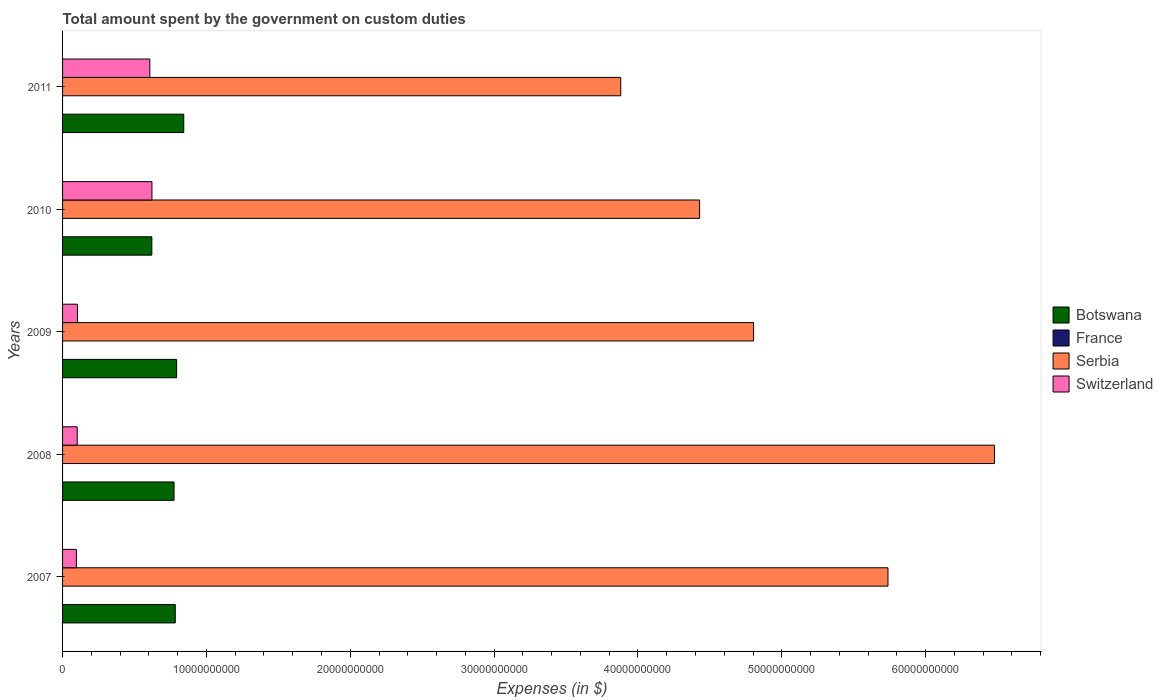How many groups of bars are there?
Your answer should be compact. 5. Are the number of bars per tick equal to the number of legend labels?
Offer a terse response. No. How many bars are there on the 4th tick from the bottom?
Provide a succinct answer. 3. What is the label of the 2nd group of bars from the top?
Make the answer very short. 2010. In how many cases, is the number of bars for a given year not equal to the number of legend labels?
Provide a succinct answer. 5. What is the amount spent on custom duties by the government in Switzerland in 2007?
Give a very brief answer. 9.61e+08. Across all years, what is the maximum amount spent on custom duties by the government in Serbia?
Provide a short and direct response. 6.48e+1. Across all years, what is the minimum amount spent on custom duties by the government in France?
Offer a terse response. 0. What is the total amount spent on custom duties by the government in France in the graph?
Offer a very short reply. 0. What is the difference between the amount spent on custom duties by the government in Serbia in 2009 and that in 2010?
Keep it short and to the point. 3.75e+09. What is the difference between the amount spent on custom duties by the government in Switzerland in 2011 and the amount spent on custom duties by the government in Serbia in 2007?
Provide a short and direct response. -5.13e+1. In the year 2008, what is the difference between the amount spent on custom duties by the government in Botswana and amount spent on custom duties by the government in Switzerland?
Offer a terse response. 6.73e+09. In how many years, is the amount spent on custom duties by the government in France greater than 66000000000 $?
Offer a very short reply. 0. What is the ratio of the amount spent on custom duties by the government in Switzerland in 2008 to that in 2011?
Provide a short and direct response. 0.17. Is the amount spent on custom duties by the government in Serbia in 2007 less than that in 2010?
Your response must be concise. No. What is the difference between the highest and the second highest amount spent on custom duties by the government in Switzerland?
Provide a succinct answer. 1.47e+08. What is the difference between the highest and the lowest amount spent on custom duties by the government in Serbia?
Offer a very short reply. 2.60e+1. Is the sum of the amount spent on custom duties by the government in Serbia in 2007 and 2009 greater than the maximum amount spent on custom duties by the government in Botswana across all years?
Your response must be concise. Yes. How many bars are there?
Keep it short and to the point. 15. What is the difference between two consecutive major ticks on the X-axis?
Provide a short and direct response. 1.00e+1. Are the values on the major ticks of X-axis written in scientific E-notation?
Offer a very short reply. No. Where does the legend appear in the graph?
Give a very brief answer. Center right. How are the legend labels stacked?
Your answer should be compact. Vertical. What is the title of the graph?
Offer a terse response. Total amount spent by the government on custom duties. Does "Monaco" appear as one of the legend labels in the graph?
Provide a short and direct response. No. What is the label or title of the X-axis?
Ensure brevity in your answer.  Expenses (in $). What is the Expenses (in $) in Botswana in 2007?
Your response must be concise. 7.83e+09. What is the Expenses (in $) of France in 2007?
Give a very brief answer. 0. What is the Expenses (in $) in Serbia in 2007?
Your response must be concise. 5.74e+1. What is the Expenses (in $) of Switzerland in 2007?
Provide a succinct answer. 9.61e+08. What is the Expenses (in $) of Botswana in 2008?
Provide a succinct answer. 7.75e+09. What is the Expenses (in $) of France in 2008?
Offer a terse response. 0. What is the Expenses (in $) of Serbia in 2008?
Ensure brevity in your answer.  6.48e+1. What is the Expenses (in $) in Switzerland in 2008?
Your response must be concise. 1.02e+09. What is the Expenses (in $) of Botswana in 2009?
Your answer should be very brief. 7.93e+09. What is the Expenses (in $) in Serbia in 2009?
Make the answer very short. 4.80e+1. What is the Expenses (in $) of Switzerland in 2009?
Your answer should be very brief. 1.03e+09. What is the Expenses (in $) in Botswana in 2010?
Make the answer very short. 6.21e+09. What is the Expenses (in $) in Serbia in 2010?
Your answer should be compact. 4.43e+1. What is the Expenses (in $) in Switzerland in 2010?
Your answer should be very brief. 6.21e+09. What is the Expenses (in $) of Botswana in 2011?
Your response must be concise. 8.42e+09. What is the Expenses (in $) of France in 2011?
Your answer should be compact. 0. What is the Expenses (in $) in Serbia in 2011?
Your answer should be compact. 3.88e+1. What is the Expenses (in $) in Switzerland in 2011?
Keep it short and to the point. 6.07e+09. Across all years, what is the maximum Expenses (in $) in Botswana?
Your answer should be very brief. 8.42e+09. Across all years, what is the maximum Expenses (in $) in Serbia?
Provide a short and direct response. 6.48e+1. Across all years, what is the maximum Expenses (in $) of Switzerland?
Provide a short and direct response. 6.21e+09. Across all years, what is the minimum Expenses (in $) of Botswana?
Give a very brief answer. 6.21e+09. Across all years, what is the minimum Expenses (in $) in Serbia?
Offer a terse response. 3.88e+1. Across all years, what is the minimum Expenses (in $) of Switzerland?
Make the answer very short. 9.61e+08. What is the total Expenses (in $) in Botswana in the graph?
Offer a terse response. 3.81e+1. What is the total Expenses (in $) in France in the graph?
Offer a terse response. 0. What is the total Expenses (in $) in Serbia in the graph?
Make the answer very short. 2.53e+11. What is the total Expenses (in $) in Switzerland in the graph?
Give a very brief answer. 1.53e+1. What is the difference between the Expenses (in $) in Botswana in 2007 and that in 2008?
Your answer should be compact. 8.47e+07. What is the difference between the Expenses (in $) in Serbia in 2007 and that in 2008?
Keep it short and to the point. -7.40e+09. What is the difference between the Expenses (in $) of Switzerland in 2007 and that in 2008?
Give a very brief answer. -5.66e+07. What is the difference between the Expenses (in $) of Botswana in 2007 and that in 2009?
Provide a short and direct response. -9.62e+07. What is the difference between the Expenses (in $) in Serbia in 2007 and that in 2009?
Your response must be concise. 9.34e+09. What is the difference between the Expenses (in $) in Switzerland in 2007 and that in 2009?
Provide a short and direct response. -7.29e+07. What is the difference between the Expenses (in $) of Botswana in 2007 and that in 2010?
Keep it short and to the point. 1.63e+09. What is the difference between the Expenses (in $) in Serbia in 2007 and that in 2010?
Offer a very short reply. 1.31e+1. What is the difference between the Expenses (in $) in Switzerland in 2007 and that in 2010?
Keep it short and to the point. -5.25e+09. What is the difference between the Expenses (in $) of Botswana in 2007 and that in 2011?
Offer a very short reply. -5.89e+08. What is the difference between the Expenses (in $) of Serbia in 2007 and that in 2011?
Offer a very short reply. 1.86e+1. What is the difference between the Expenses (in $) of Switzerland in 2007 and that in 2011?
Your answer should be compact. -5.11e+09. What is the difference between the Expenses (in $) in Botswana in 2008 and that in 2009?
Ensure brevity in your answer.  -1.81e+08. What is the difference between the Expenses (in $) in Serbia in 2008 and that in 2009?
Provide a short and direct response. 1.67e+1. What is the difference between the Expenses (in $) in Switzerland in 2008 and that in 2009?
Offer a terse response. -1.63e+07. What is the difference between the Expenses (in $) of Botswana in 2008 and that in 2010?
Provide a short and direct response. 1.54e+09. What is the difference between the Expenses (in $) in Serbia in 2008 and that in 2010?
Give a very brief answer. 2.05e+1. What is the difference between the Expenses (in $) of Switzerland in 2008 and that in 2010?
Keep it short and to the point. -5.20e+09. What is the difference between the Expenses (in $) of Botswana in 2008 and that in 2011?
Provide a succinct answer. -6.74e+08. What is the difference between the Expenses (in $) in Serbia in 2008 and that in 2011?
Give a very brief answer. 2.60e+1. What is the difference between the Expenses (in $) of Switzerland in 2008 and that in 2011?
Provide a short and direct response. -5.05e+09. What is the difference between the Expenses (in $) in Botswana in 2009 and that in 2010?
Make the answer very short. 1.72e+09. What is the difference between the Expenses (in $) in Serbia in 2009 and that in 2010?
Ensure brevity in your answer.  3.75e+09. What is the difference between the Expenses (in $) in Switzerland in 2009 and that in 2010?
Provide a short and direct response. -5.18e+09. What is the difference between the Expenses (in $) of Botswana in 2009 and that in 2011?
Keep it short and to the point. -4.93e+08. What is the difference between the Expenses (in $) in Serbia in 2009 and that in 2011?
Provide a short and direct response. 9.24e+09. What is the difference between the Expenses (in $) of Switzerland in 2009 and that in 2011?
Keep it short and to the point. -5.03e+09. What is the difference between the Expenses (in $) of Botswana in 2010 and that in 2011?
Ensure brevity in your answer.  -2.22e+09. What is the difference between the Expenses (in $) of Serbia in 2010 and that in 2011?
Your answer should be compact. 5.48e+09. What is the difference between the Expenses (in $) of Switzerland in 2010 and that in 2011?
Provide a succinct answer. 1.47e+08. What is the difference between the Expenses (in $) in Botswana in 2007 and the Expenses (in $) in Serbia in 2008?
Offer a very short reply. -5.69e+1. What is the difference between the Expenses (in $) of Botswana in 2007 and the Expenses (in $) of Switzerland in 2008?
Your answer should be very brief. 6.82e+09. What is the difference between the Expenses (in $) in Serbia in 2007 and the Expenses (in $) in Switzerland in 2008?
Your answer should be compact. 5.64e+1. What is the difference between the Expenses (in $) in Botswana in 2007 and the Expenses (in $) in Serbia in 2009?
Your answer should be compact. -4.02e+1. What is the difference between the Expenses (in $) in Botswana in 2007 and the Expenses (in $) in Switzerland in 2009?
Offer a very short reply. 6.80e+09. What is the difference between the Expenses (in $) in Serbia in 2007 and the Expenses (in $) in Switzerland in 2009?
Your answer should be very brief. 5.63e+1. What is the difference between the Expenses (in $) of Botswana in 2007 and the Expenses (in $) of Serbia in 2010?
Ensure brevity in your answer.  -3.65e+1. What is the difference between the Expenses (in $) of Botswana in 2007 and the Expenses (in $) of Switzerland in 2010?
Provide a short and direct response. 1.62e+09. What is the difference between the Expenses (in $) in Serbia in 2007 and the Expenses (in $) in Switzerland in 2010?
Your answer should be very brief. 5.12e+1. What is the difference between the Expenses (in $) in Botswana in 2007 and the Expenses (in $) in Serbia in 2011?
Keep it short and to the point. -3.10e+1. What is the difference between the Expenses (in $) of Botswana in 2007 and the Expenses (in $) of Switzerland in 2011?
Provide a short and direct response. 1.77e+09. What is the difference between the Expenses (in $) in Serbia in 2007 and the Expenses (in $) in Switzerland in 2011?
Provide a short and direct response. 5.13e+1. What is the difference between the Expenses (in $) in Botswana in 2008 and the Expenses (in $) in Serbia in 2009?
Your answer should be very brief. -4.03e+1. What is the difference between the Expenses (in $) in Botswana in 2008 and the Expenses (in $) in Switzerland in 2009?
Offer a very short reply. 6.72e+09. What is the difference between the Expenses (in $) in Serbia in 2008 and the Expenses (in $) in Switzerland in 2009?
Make the answer very short. 6.38e+1. What is the difference between the Expenses (in $) of Botswana in 2008 and the Expenses (in $) of Serbia in 2010?
Your response must be concise. -3.65e+1. What is the difference between the Expenses (in $) of Botswana in 2008 and the Expenses (in $) of Switzerland in 2010?
Give a very brief answer. 1.54e+09. What is the difference between the Expenses (in $) of Serbia in 2008 and the Expenses (in $) of Switzerland in 2010?
Offer a terse response. 5.86e+1. What is the difference between the Expenses (in $) of Botswana in 2008 and the Expenses (in $) of Serbia in 2011?
Offer a very short reply. -3.11e+1. What is the difference between the Expenses (in $) in Botswana in 2008 and the Expenses (in $) in Switzerland in 2011?
Ensure brevity in your answer.  1.68e+09. What is the difference between the Expenses (in $) in Serbia in 2008 and the Expenses (in $) in Switzerland in 2011?
Ensure brevity in your answer.  5.87e+1. What is the difference between the Expenses (in $) of Botswana in 2009 and the Expenses (in $) of Serbia in 2010?
Provide a succinct answer. -3.64e+1. What is the difference between the Expenses (in $) in Botswana in 2009 and the Expenses (in $) in Switzerland in 2010?
Ensure brevity in your answer.  1.72e+09. What is the difference between the Expenses (in $) in Serbia in 2009 and the Expenses (in $) in Switzerland in 2010?
Offer a terse response. 4.18e+1. What is the difference between the Expenses (in $) in Botswana in 2009 and the Expenses (in $) in Serbia in 2011?
Provide a succinct answer. -3.09e+1. What is the difference between the Expenses (in $) in Botswana in 2009 and the Expenses (in $) in Switzerland in 2011?
Offer a terse response. 1.87e+09. What is the difference between the Expenses (in $) of Serbia in 2009 and the Expenses (in $) of Switzerland in 2011?
Make the answer very short. 4.20e+1. What is the difference between the Expenses (in $) in Botswana in 2010 and the Expenses (in $) in Serbia in 2011?
Provide a succinct answer. -3.26e+1. What is the difference between the Expenses (in $) in Botswana in 2010 and the Expenses (in $) in Switzerland in 2011?
Your answer should be compact. 1.41e+08. What is the difference between the Expenses (in $) in Serbia in 2010 and the Expenses (in $) in Switzerland in 2011?
Ensure brevity in your answer.  3.82e+1. What is the average Expenses (in $) of Botswana per year?
Make the answer very short. 7.63e+09. What is the average Expenses (in $) in Serbia per year?
Your answer should be compact. 5.07e+1. What is the average Expenses (in $) of Switzerland per year?
Your response must be concise. 3.06e+09. In the year 2007, what is the difference between the Expenses (in $) in Botswana and Expenses (in $) in Serbia?
Give a very brief answer. -4.95e+1. In the year 2007, what is the difference between the Expenses (in $) of Botswana and Expenses (in $) of Switzerland?
Offer a very short reply. 6.87e+09. In the year 2007, what is the difference between the Expenses (in $) of Serbia and Expenses (in $) of Switzerland?
Give a very brief answer. 5.64e+1. In the year 2008, what is the difference between the Expenses (in $) in Botswana and Expenses (in $) in Serbia?
Keep it short and to the point. -5.70e+1. In the year 2008, what is the difference between the Expenses (in $) of Botswana and Expenses (in $) of Switzerland?
Your answer should be very brief. 6.73e+09. In the year 2008, what is the difference between the Expenses (in $) in Serbia and Expenses (in $) in Switzerland?
Provide a succinct answer. 6.38e+1. In the year 2009, what is the difference between the Expenses (in $) in Botswana and Expenses (in $) in Serbia?
Give a very brief answer. -4.01e+1. In the year 2009, what is the difference between the Expenses (in $) of Botswana and Expenses (in $) of Switzerland?
Your answer should be very brief. 6.90e+09. In the year 2009, what is the difference between the Expenses (in $) in Serbia and Expenses (in $) in Switzerland?
Keep it short and to the point. 4.70e+1. In the year 2010, what is the difference between the Expenses (in $) in Botswana and Expenses (in $) in Serbia?
Offer a terse response. -3.81e+1. In the year 2010, what is the difference between the Expenses (in $) of Botswana and Expenses (in $) of Switzerland?
Your answer should be compact. -6.58e+06. In the year 2010, what is the difference between the Expenses (in $) of Serbia and Expenses (in $) of Switzerland?
Your answer should be compact. 3.81e+1. In the year 2011, what is the difference between the Expenses (in $) of Botswana and Expenses (in $) of Serbia?
Offer a terse response. -3.04e+1. In the year 2011, what is the difference between the Expenses (in $) in Botswana and Expenses (in $) in Switzerland?
Your response must be concise. 2.36e+09. In the year 2011, what is the difference between the Expenses (in $) of Serbia and Expenses (in $) of Switzerland?
Keep it short and to the point. 3.27e+1. What is the ratio of the Expenses (in $) in Botswana in 2007 to that in 2008?
Provide a succinct answer. 1.01. What is the ratio of the Expenses (in $) in Serbia in 2007 to that in 2008?
Offer a very short reply. 0.89. What is the ratio of the Expenses (in $) in Botswana in 2007 to that in 2009?
Offer a very short reply. 0.99. What is the ratio of the Expenses (in $) of Serbia in 2007 to that in 2009?
Provide a short and direct response. 1.19. What is the ratio of the Expenses (in $) of Switzerland in 2007 to that in 2009?
Provide a short and direct response. 0.93. What is the ratio of the Expenses (in $) in Botswana in 2007 to that in 2010?
Ensure brevity in your answer.  1.26. What is the ratio of the Expenses (in $) in Serbia in 2007 to that in 2010?
Keep it short and to the point. 1.3. What is the ratio of the Expenses (in $) of Switzerland in 2007 to that in 2010?
Provide a short and direct response. 0.15. What is the ratio of the Expenses (in $) of Serbia in 2007 to that in 2011?
Keep it short and to the point. 1.48. What is the ratio of the Expenses (in $) of Switzerland in 2007 to that in 2011?
Make the answer very short. 0.16. What is the ratio of the Expenses (in $) of Botswana in 2008 to that in 2009?
Make the answer very short. 0.98. What is the ratio of the Expenses (in $) in Serbia in 2008 to that in 2009?
Offer a very short reply. 1.35. What is the ratio of the Expenses (in $) of Switzerland in 2008 to that in 2009?
Your answer should be very brief. 0.98. What is the ratio of the Expenses (in $) in Botswana in 2008 to that in 2010?
Your answer should be compact. 1.25. What is the ratio of the Expenses (in $) in Serbia in 2008 to that in 2010?
Keep it short and to the point. 1.46. What is the ratio of the Expenses (in $) of Switzerland in 2008 to that in 2010?
Give a very brief answer. 0.16. What is the ratio of the Expenses (in $) of Serbia in 2008 to that in 2011?
Offer a very short reply. 1.67. What is the ratio of the Expenses (in $) of Switzerland in 2008 to that in 2011?
Your response must be concise. 0.17. What is the ratio of the Expenses (in $) in Botswana in 2009 to that in 2010?
Make the answer very short. 1.28. What is the ratio of the Expenses (in $) of Serbia in 2009 to that in 2010?
Give a very brief answer. 1.08. What is the ratio of the Expenses (in $) in Switzerland in 2009 to that in 2010?
Your answer should be very brief. 0.17. What is the ratio of the Expenses (in $) of Botswana in 2009 to that in 2011?
Provide a short and direct response. 0.94. What is the ratio of the Expenses (in $) of Serbia in 2009 to that in 2011?
Offer a very short reply. 1.24. What is the ratio of the Expenses (in $) in Switzerland in 2009 to that in 2011?
Give a very brief answer. 0.17. What is the ratio of the Expenses (in $) of Botswana in 2010 to that in 2011?
Ensure brevity in your answer.  0.74. What is the ratio of the Expenses (in $) of Serbia in 2010 to that in 2011?
Your answer should be compact. 1.14. What is the ratio of the Expenses (in $) in Switzerland in 2010 to that in 2011?
Provide a short and direct response. 1.02. What is the difference between the highest and the second highest Expenses (in $) of Botswana?
Your response must be concise. 4.93e+08. What is the difference between the highest and the second highest Expenses (in $) of Serbia?
Provide a short and direct response. 7.40e+09. What is the difference between the highest and the second highest Expenses (in $) of Switzerland?
Your answer should be very brief. 1.47e+08. What is the difference between the highest and the lowest Expenses (in $) of Botswana?
Your answer should be compact. 2.22e+09. What is the difference between the highest and the lowest Expenses (in $) of Serbia?
Provide a succinct answer. 2.60e+1. What is the difference between the highest and the lowest Expenses (in $) of Switzerland?
Provide a short and direct response. 5.25e+09. 